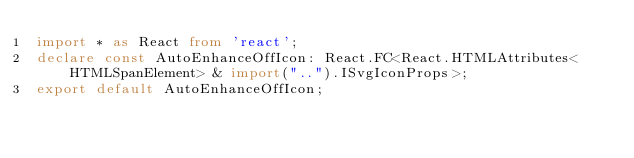Convert code to text. <code><loc_0><loc_0><loc_500><loc_500><_TypeScript_>import * as React from 'react';
declare const AutoEnhanceOffIcon: React.FC<React.HTMLAttributes<HTMLSpanElement> & import("..").ISvgIconProps>;
export default AutoEnhanceOffIcon;
</code> 